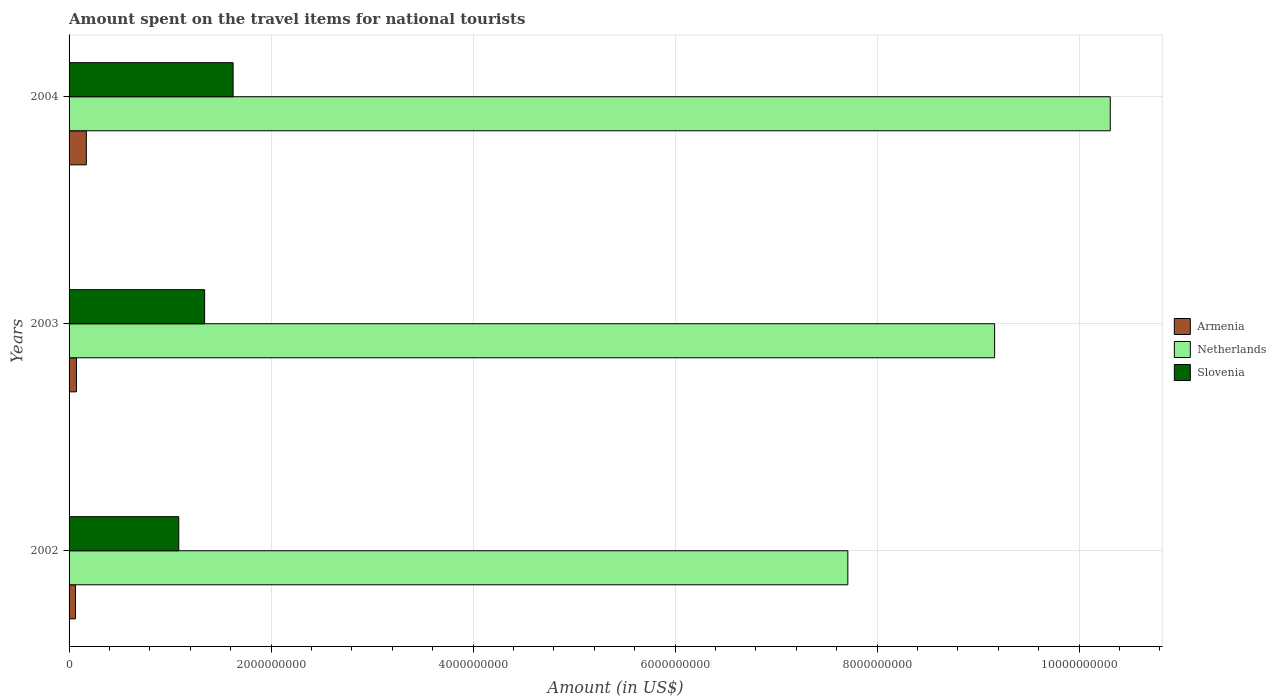How many groups of bars are there?
Provide a succinct answer. 3. Are the number of bars per tick equal to the number of legend labels?
Keep it short and to the point. Yes. What is the amount spent on the travel items for national tourists in Slovenia in 2002?
Ensure brevity in your answer.  1.09e+09. Across all years, what is the maximum amount spent on the travel items for national tourists in Armenia?
Your answer should be very brief. 1.71e+08. Across all years, what is the minimum amount spent on the travel items for national tourists in Armenia?
Your answer should be very brief. 6.30e+07. In which year was the amount spent on the travel items for national tourists in Netherlands maximum?
Your answer should be compact. 2004. What is the total amount spent on the travel items for national tourists in Netherlands in the graph?
Provide a succinct answer. 2.72e+1. What is the difference between the amount spent on the travel items for national tourists in Netherlands in 2002 and that in 2003?
Provide a short and direct response. -1.45e+09. What is the difference between the amount spent on the travel items for national tourists in Armenia in 2004 and the amount spent on the travel items for national tourists in Netherlands in 2003?
Your response must be concise. -8.99e+09. What is the average amount spent on the travel items for national tourists in Armenia per year?
Provide a succinct answer. 1.02e+08. In the year 2003, what is the difference between the amount spent on the travel items for national tourists in Armenia and amount spent on the travel items for national tourists in Slovenia?
Ensure brevity in your answer.  -1.27e+09. What is the ratio of the amount spent on the travel items for national tourists in Armenia in 2002 to that in 2003?
Ensure brevity in your answer.  0.86. Is the amount spent on the travel items for national tourists in Armenia in 2003 less than that in 2004?
Provide a short and direct response. Yes. Is the difference between the amount spent on the travel items for national tourists in Armenia in 2002 and 2004 greater than the difference between the amount spent on the travel items for national tourists in Slovenia in 2002 and 2004?
Make the answer very short. Yes. What is the difference between the highest and the second highest amount spent on the travel items for national tourists in Slovenia?
Your answer should be very brief. 2.82e+08. What is the difference between the highest and the lowest amount spent on the travel items for national tourists in Netherlands?
Offer a very short reply. 2.60e+09. In how many years, is the amount spent on the travel items for national tourists in Slovenia greater than the average amount spent on the travel items for national tourists in Slovenia taken over all years?
Your answer should be very brief. 1. What does the 3rd bar from the top in 2004 represents?
Keep it short and to the point. Armenia. What does the 2nd bar from the bottom in 2002 represents?
Offer a very short reply. Netherlands. Is it the case that in every year, the sum of the amount spent on the travel items for national tourists in Armenia and amount spent on the travel items for national tourists in Slovenia is greater than the amount spent on the travel items for national tourists in Netherlands?
Your answer should be compact. No. How many bars are there?
Provide a succinct answer. 9. Are all the bars in the graph horizontal?
Make the answer very short. Yes. How many years are there in the graph?
Offer a terse response. 3. What is the difference between two consecutive major ticks on the X-axis?
Your response must be concise. 2.00e+09. Are the values on the major ticks of X-axis written in scientific E-notation?
Keep it short and to the point. No. Does the graph contain any zero values?
Your answer should be very brief. No. How are the legend labels stacked?
Offer a very short reply. Vertical. What is the title of the graph?
Give a very brief answer. Amount spent on the travel items for national tourists. What is the Amount (in US$) in Armenia in 2002?
Make the answer very short. 6.30e+07. What is the Amount (in US$) of Netherlands in 2002?
Your answer should be very brief. 7.71e+09. What is the Amount (in US$) of Slovenia in 2002?
Ensure brevity in your answer.  1.09e+09. What is the Amount (in US$) of Armenia in 2003?
Your answer should be compact. 7.30e+07. What is the Amount (in US$) in Netherlands in 2003?
Offer a very short reply. 9.16e+09. What is the Amount (in US$) of Slovenia in 2003?
Offer a very short reply. 1.34e+09. What is the Amount (in US$) of Armenia in 2004?
Make the answer very short. 1.71e+08. What is the Amount (in US$) in Netherlands in 2004?
Provide a succinct answer. 1.03e+1. What is the Amount (in US$) in Slovenia in 2004?
Ensure brevity in your answer.  1.62e+09. Across all years, what is the maximum Amount (in US$) in Armenia?
Provide a succinct answer. 1.71e+08. Across all years, what is the maximum Amount (in US$) of Netherlands?
Your answer should be very brief. 1.03e+1. Across all years, what is the maximum Amount (in US$) in Slovenia?
Provide a succinct answer. 1.62e+09. Across all years, what is the minimum Amount (in US$) of Armenia?
Offer a terse response. 6.30e+07. Across all years, what is the minimum Amount (in US$) in Netherlands?
Give a very brief answer. 7.71e+09. Across all years, what is the minimum Amount (in US$) in Slovenia?
Make the answer very short. 1.09e+09. What is the total Amount (in US$) of Armenia in the graph?
Your answer should be compact. 3.07e+08. What is the total Amount (in US$) in Netherlands in the graph?
Offer a terse response. 2.72e+1. What is the total Amount (in US$) in Slovenia in the graph?
Your response must be concise. 4.05e+09. What is the difference between the Amount (in US$) of Armenia in 2002 and that in 2003?
Your answer should be very brief. -1.00e+07. What is the difference between the Amount (in US$) in Netherlands in 2002 and that in 2003?
Provide a short and direct response. -1.45e+09. What is the difference between the Amount (in US$) of Slovenia in 2002 and that in 2003?
Keep it short and to the point. -2.56e+08. What is the difference between the Amount (in US$) in Armenia in 2002 and that in 2004?
Provide a short and direct response. -1.08e+08. What is the difference between the Amount (in US$) in Netherlands in 2002 and that in 2004?
Give a very brief answer. -2.60e+09. What is the difference between the Amount (in US$) in Slovenia in 2002 and that in 2004?
Give a very brief answer. -5.38e+08. What is the difference between the Amount (in US$) in Armenia in 2003 and that in 2004?
Your response must be concise. -9.80e+07. What is the difference between the Amount (in US$) of Netherlands in 2003 and that in 2004?
Offer a terse response. -1.14e+09. What is the difference between the Amount (in US$) of Slovenia in 2003 and that in 2004?
Your answer should be very brief. -2.82e+08. What is the difference between the Amount (in US$) in Armenia in 2002 and the Amount (in US$) in Netherlands in 2003?
Make the answer very short. -9.10e+09. What is the difference between the Amount (in US$) in Armenia in 2002 and the Amount (in US$) in Slovenia in 2003?
Offer a terse response. -1.28e+09. What is the difference between the Amount (in US$) of Netherlands in 2002 and the Amount (in US$) of Slovenia in 2003?
Keep it short and to the point. 6.37e+09. What is the difference between the Amount (in US$) of Armenia in 2002 and the Amount (in US$) of Netherlands in 2004?
Give a very brief answer. -1.02e+1. What is the difference between the Amount (in US$) in Armenia in 2002 and the Amount (in US$) in Slovenia in 2004?
Offer a terse response. -1.56e+09. What is the difference between the Amount (in US$) in Netherlands in 2002 and the Amount (in US$) in Slovenia in 2004?
Give a very brief answer. 6.09e+09. What is the difference between the Amount (in US$) in Armenia in 2003 and the Amount (in US$) in Netherlands in 2004?
Make the answer very short. -1.02e+1. What is the difference between the Amount (in US$) of Armenia in 2003 and the Amount (in US$) of Slovenia in 2004?
Provide a succinct answer. -1.55e+09. What is the difference between the Amount (in US$) of Netherlands in 2003 and the Amount (in US$) of Slovenia in 2004?
Ensure brevity in your answer.  7.54e+09. What is the average Amount (in US$) of Armenia per year?
Give a very brief answer. 1.02e+08. What is the average Amount (in US$) of Netherlands per year?
Offer a very short reply. 9.06e+09. What is the average Amount (in US$) of Slovenia per year?
Provide a succinct answer. 1.35e+09. In the year 2002, what is the difference between the Amount (in US$) in Armenia and Amount (in US$) in Netherlands?
Offer a very short reply. -7.65e+09. In the year 2002, what is the difference between the Amount (in US$) in Armenia and Amount (in US$) in Slovenia?
Keep it short and to the point. -1.02e+09. In the year 2002, what is the difference between the Amount (in US$) in Netherlands and Amount (in US$) in Slovenia?
Provide a succinct answer. 6.62e+09. In the year 2003, what is the difference between the Amount (in US$) in Armenia and Amount (in US$) in Netherlands?
Your answer should be very brief. -9.09e+09. In the year 2003, what is the difference between the Amount (in US$) in Armenia and Amount (in US$) in Slovenia?
Your answer should be very brief. -1.27e+09. In the year 2003, what is the difference between the Amount (in US$) in Netherlands and Amount (in US$) in Slovenia?
Ensure brevity in your answer.  7.82e+09. In the year 2004, what is the difference between the Amount (in US$) in Armenia and Amount (in US$) in Netherlands?
Your answer should be compact. -1.01e+1. In the year 2004, what is the difference between the Amount (in US$) in Armenia and Amount (in US$) in Slovenia?
Keep it short and to the point. -1.45e+09. In the year 2004, what is the difference between the Amount (in US$) in Netherlands and Amount (in US$) in Slovenia?
Offer a very short reply. 8.68e+09. What is the ratio of the Amount (in US$) in Armenia in 2002 to that in 2003?
Offer a terse response. 0.86. What is the ratio of the Amount (in US$) in Netherlands in 2002 to that in 2003?
Your answer should be very brief. 0.84. What is the ratio of the Amount (in US$) of Slovenia in 2002 to that in 2003?
Give a very brief answer. 0.81. What is the ratio of the Amount (in US$) of Armenia in 2002 to that in 2004?
Provide a short and direct response. 0.37. What is the ratio of the Amount (in US$) in Netherlands in 2002 to that in 2004?
Offer a terse response. 0.75. What is the ratio of the Amount (in US$) of Slovenia in 2002 to that in 2004?
Make the answer very short. 0.67. What is the ratio of the Amount (in US$) of Armenia in 2003 to that in 2004?
Make the answer very short. 0.43. What is the ratio of the Amount (in US$) of Slovenia in 2003 to that in 2004?
Offer a very short reply. 0.83. What is the difference between the highest and the second highest Amount (in US$) of Armenia?
Offer a very short reply. 9.80e+07. What is the difference between the highest and the second highest Amount (in US$) in Netherlands?
Your response must be concise. 1.14e+09. What is the difference between the highest and the second highest Amount (in US$) of Slovenia?
Give a very brief answer. 2.82e+08. What is the difference between the highest and the lowest Amount (in US$) of Armenia?
Your answer should be compact. 1.08e+08. What is the difference between the highest and the lowest Amount (in US$) of Netherlands?
Provide a succinct answer. 2.60e+09. What is the difference between the highest and the lowest Amount (in US$) in Slovenia?
Your answer should be very brief. 5.38e+08. 